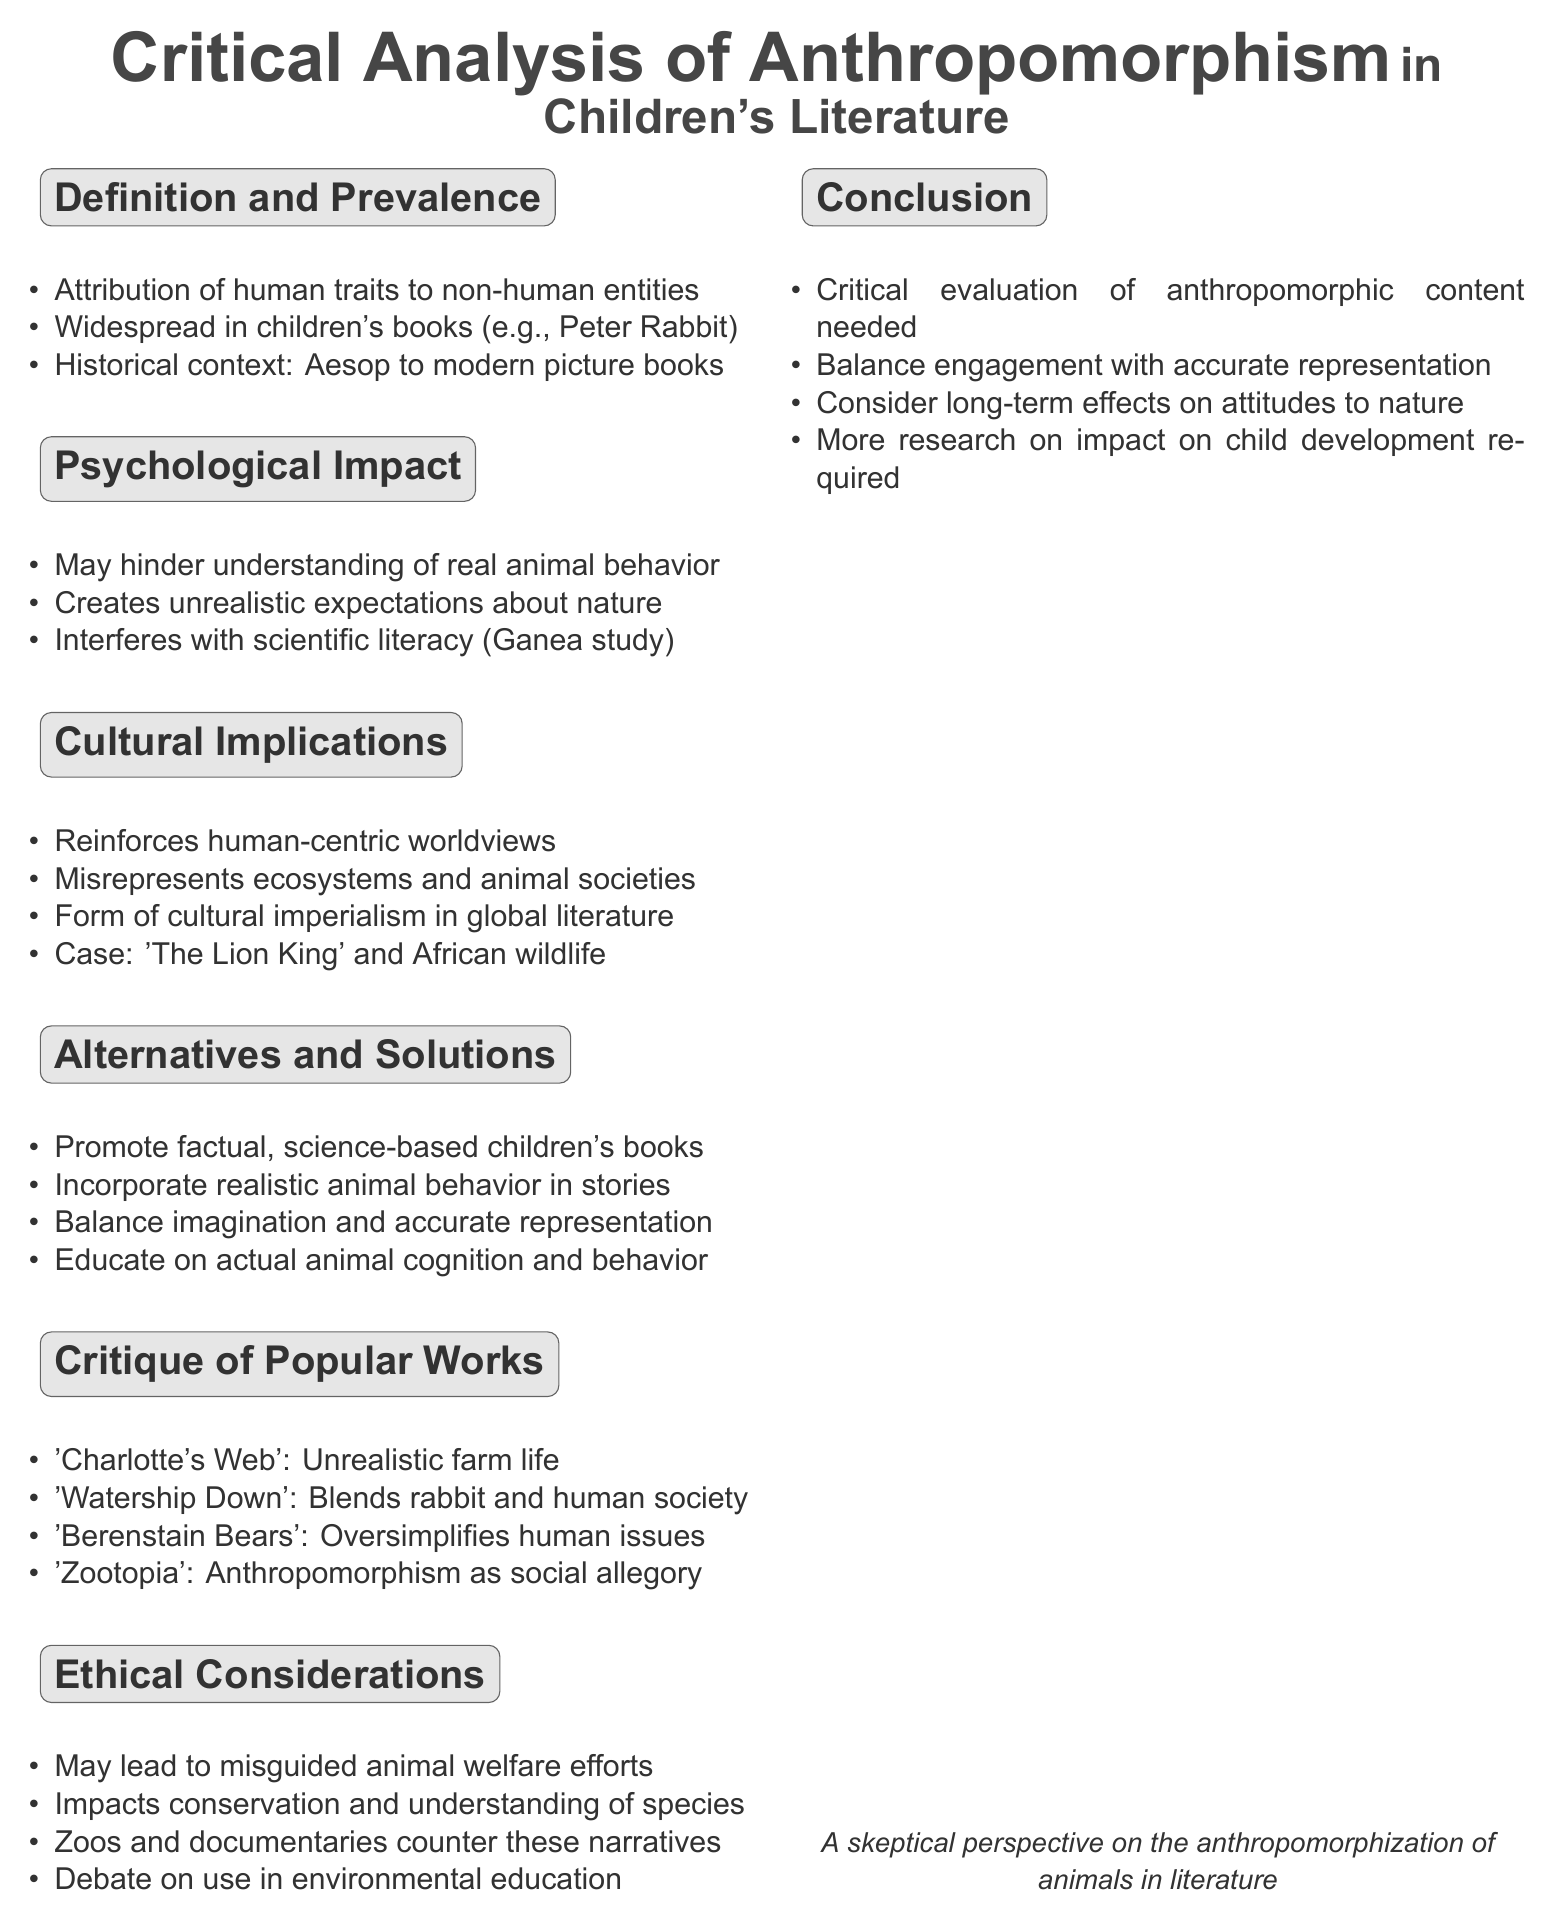What is anthropomorphism? Anthropomorphism is the attribution of human characteristics to non-human entities.
Answer: Attribution of human characteristics to non-human entities Which case study is mentioned regarding cultural implications? The document references Disney's 'The Lion King' as a case study for cultural implications of anthropomorphism.
Answer: Disney's 'The Lion King' What does Dr. Patricia Ganea's study focus on? The study examines factual learning from anthropomorphic books.
Answer: Factual learning from anthropomorphic books Name an alternative to anthropomorphic children's books suggested in the document. The document suggests promoting factual, science-based children's books as an alternative.
Answer: Factual, science-based children's books What animal story is analyzed for its portrayal of farm life? The document critiques 'Charlotte's Web' for its unrealistic portrayal of farm life.
Answer: 'Charlotte's Web' 